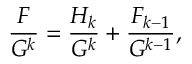Convert formula to latex. <formula><loc_0><loc_0><loc_500><loc_500>{ \frac { F } { G ^ { k } } } = { \frac { H _ { k } } { G ^ { k } } } + { \frac { F _ { k - 1 } } { G ^ { k - 1 } } } ,</formula> 